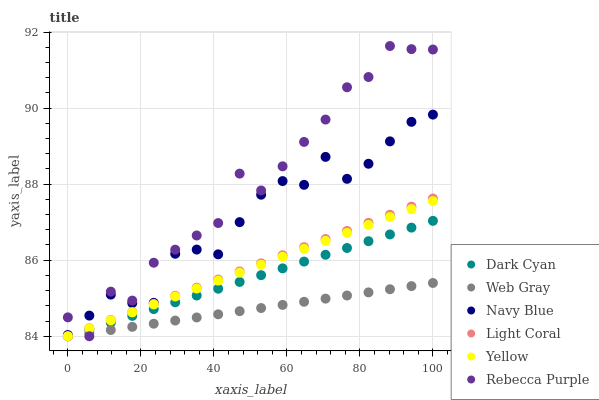Does Web Gray have the minimum area under the curve?
Answer yes or no. Yes. Does Rebecca Purple have the maximum area under the curve?
Answer yes or no. Yes. Does Navy Blue have the minimum area under the curve?
Answer yes or no. No. Does Navy Blue have the maximum area under the curve?
Answer yes or no. No. Is Web Gray the smoothest?
Answer yes or no. Yes. Is Rebecca Purple the roughest?
Answer yes or no. Yes. Is Navy Blue the smoothest?
Answer yes or no. No. Is Navy Blue the roughest?
Answer yes or no. No. Does Web Gray have the lowest value?
Answer yes or no. Yes. Does Navy Blue have the lowest value?
Answer yes or no. No. Does Rebecca Purple have the highest value?
Answer yes or no. Yes. Does Navy Blue have the highest value?
Answer yes or no. No. Is Web Gray less than Navy Blue?
Answer yes or no. Yes. Is Navy Blue greater than Light Coral?
Answer yes or no. Yes. Does Rebecca Purple intersect Yellow?
Answer yes or no. Yes. Is Rebecca Purple less than Yellow?
Answer yes or no. No. Is Rebecca Purple greater than Yellow?
Answer yes or no. No. Does Web Gray intersect Navy Blue?
Answer yes or no. No. 